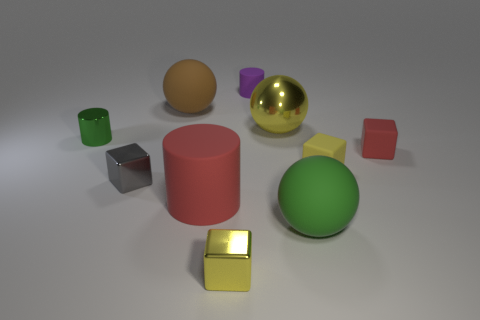There is a green thing that is the same shape as the big red matte object; what is its material?
Offer a very short reply. Metal. What is the material of the cylinder that is in front of the big yellow sphere and right of the small metal cylinder?
Keep it short and to the point. Rubber. How many other objects are the same shape as the small gray thing?
Give a very brief answer. 3. There is a shiny thing in front of the green matte thing to the right of the metallic cylinder; what is its color?
Give a very brief answer. Yellow. Are there an equal number of purple cylinders in front of the red block and large purple rubber cylinders?
Your answer should be compact. Yes. Is there a shiny thing of the same size as the metal cylinder?
Offer a very short reply. Yes. Does the yellow sphere have the same size as the rubber thing behind the brown matte ball?
Provide a short and direct response. No. Are there the same number of large brown rubber balls in front of the small red matte thing and rubber cylinders behind the big red rubber thing?
Give a very brief answer. No. There is a rubber object that is the same color as the big metal object; what shape is it?
Ensure brevity in your answer.  Cube. What is the green object to the right of the large brown sphere made of?
Offer a terse response. Rubber. 